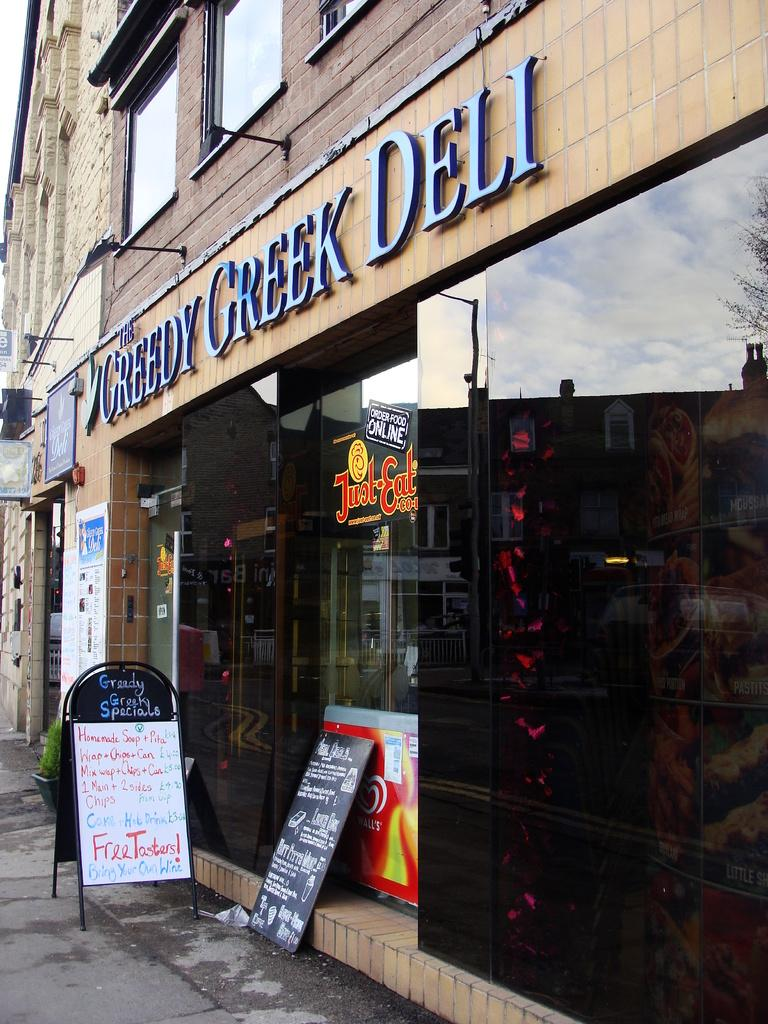What type of structures can be seen in the image? There are posts, posters, and buildings in the image. Can you describe the posts in the image? The posts are vertical structures that may be used for support or signage. What is depicted on the posters in the image? The content of the posters cannot be determined from the provided facts. What type of structures are the buildings in the image? The buildings in the image are man-made structures that provide shelter or serve a specific function. What type of corn can be seen growing near the buildings in the image? There is no corn present in the image; it only features posts, posters, and buildings. How many clovers are visible on the posters in the image? There is no mention of clovers in the image, as it only features posts, posters, and buildings. 